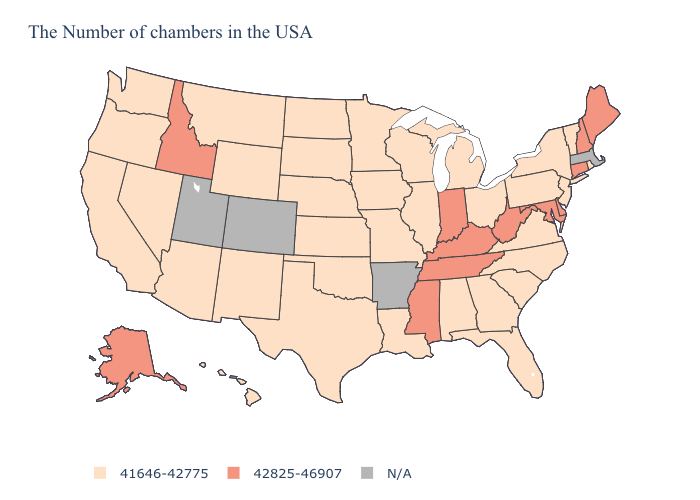Which states hav the highest value in the South?
Write a very short answer. Delaware, Maryland, West Virginia, Kentucky, Tennessee, Mississippi. How many symbols are there in the legend?
Quick response, please. 3. Which states have the lowest value in the USA?
Answer briefly. Rhode Island, Vermont, New York, New Jersey, Pennsylvania, Virginia, North Carolina, South Carolina, Ohio, Florida, Georgia, Michigan, Alabama, Wisconsin, Illinois, Louisiana, Missouri, Minnesota, Iowa, Kansas, Nebraska, Oklahoma, Texas, South Dakota, North Dakota, Wyoming, New Mexico, Montana, Arizona, Nevada, California, Washington, Oregon, Hawaii. What is the lowest value in the MidWest?
Keep it brief. 41646-42775. Among the states that border Nebraska , which have the lowest value?
Give a very brief answer. Missouri, Iowa, Kansas, South Dakota, Wyoming. Name the states that have a value in the range 42825-46907?
Short answer required. Maine, New Hampshire, Connecticut, Delaware, Maryland, West Virginia, Kentucky, Indiana, Tennessee, Mississippi, Idaho, Alaska. Name the states that have a value in the range N/A?
Write a very short answer. Massachusetts, Arkansas, Colorado, Utah. Does the map have missing data?
Answer briefly. Yes. Name the states that have a value in the range 41646-42775?
Answer briefly. Rhode Island, Vermont, New York, New Jersey, Pennsylvania, Virginia, North Carolina, South Carolina, Ohio, Florida, Georgia, Michigan, Alabama, Wisconsin, Illinois, Louisiana, Missouri, Minnesota, Iowa, Kansas, Nebraska, Oklahoma, Texas, South Dakota, North Dakota, Wyoming, New Mexico, Montana, Arizona, Nevada, California, Washington, Oregon, Hawaii. What is the value of Hawaii?
Keep it brief. 41646-42775. Does Nebraska have the highest value in the MidWest?
Write a very short answer. No. Among the states that border Virginia , which have the lowest value?
Answer briefly. North Carolina. Name the states that have a value in the range N/A?
Give a very brief answer. Massachusetts, Arkansas, Colorado, Utah. Which states have the highest value in the USA?
Give a very brief answer. Maine, New Hampshire, Connecticut, Delaware, Maryland, West Virginia, Kentucky, Indiana, Tennessee, Mississippi, Idaho, Alaska. 